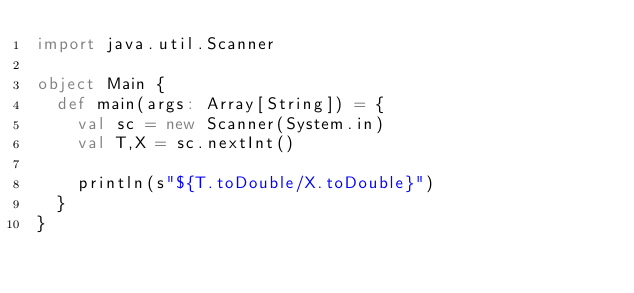<code> <loc_0><loc_0><loc_500><loc_500><_Scala_>import java.util.Scanner

object Main {
  def main(args: Array[String]) = {
    val sc = new Scanner(System.in)
    val T,X = sc.nextInt()

    println(s"${T.toDouble/X.toDouble}")
  }
}</code> 